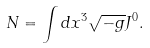<formula> <loc_0><loc_0><loc_500><loc_500>N = \int d x ^ { 3 } \sqrt { - g } J ^ { 0 } .</formula> 